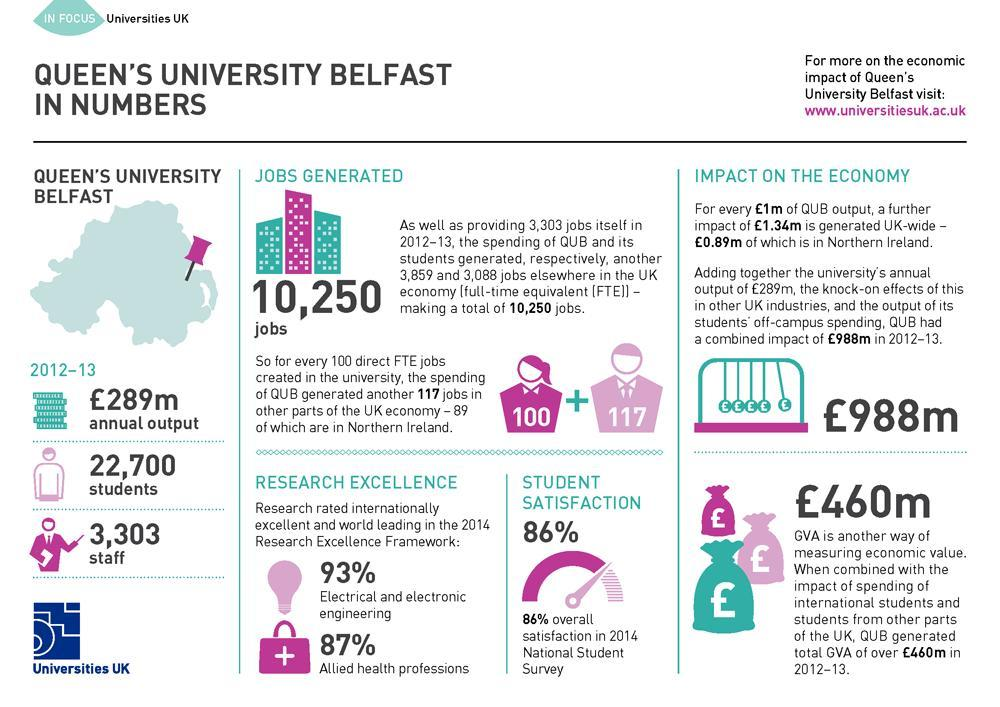How many students were enrolled in the Queen's University Belfast during 2012-13?
Answer the question with a short phrase. 22,700 What is the percent of overall satisfaction in 2014 National Student Survey? 86% How many staffs were working in the Queen's University Belfast during 2012-13? 3,303 